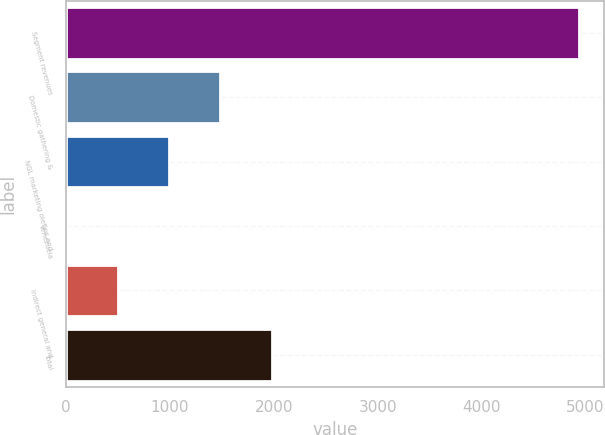Convert chart. <chart><loc_0><loc_0><loc_500><loc_500><bar_chart><fcel>Segment revenues<fcel>Domestic gathering &<fcel>NGL marketing olefins and<fcel>Venezuela<fcel>Indirect general and<fcel>Total<nl><fcel>4933<fcel>1487.6<fcel>995.4<fcel>11<fcel>503.2<fcel>1979.8<nl></chart> 